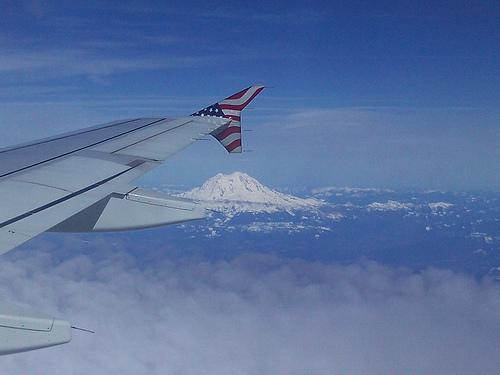Using as many details as possible, describe the view from the airplane. An airplane flying in a sunny clear blue sky, with a lot of white clouds below, snowy mountains in the distance, and the American flag printed on a wing. Count the number of mountains and describe their appearance in the image. There are two primary mountains, a large snow-covered mountain and a smaller mountain in the back, with a snowy landscape and rocks around them. Consider the elements in the image and summarize them while expressing a sense of admiration. An awe-inspiring view of an airplane with a patriotic wing soaring above mesmerizing clouds and majestic snow-capped mountains on a bright, sunny day. Can you provide a brief summary of the image's overall scenery? The image captures an airplane flying over snowy mountains and clouds, with a clear blue sky on a sunny day. What is the primary object and focus of this image? The primary object and focus is an airplane with a decorated wing, flying over clouds and mountains. Explain how the image might make someone feel who is looking at it. The image might evoke feelings of adventure, excitement, and freedom as the viewer observes the airplane flying above the clouds and snowy mountains on a sunny day. In the image, what type of natural formations are present, and how do they appear? There are large snow-covered mountains and smaller mountains in the background, with rocks out around the mountain, and fluffy white clouds below the plane. What is in the image regarding the weather? A clear blue sky with many fluffy white clouds in the sky, and it's a beautiful sunny day. What are some of the distinct features and details visible on the airplane's wing? An American flag design, a small wire sticking out of the wing, metal fuselage, flap on the wing, a wing fin on a jet plane, and white and red patterns. Identify and describe the flying object in the image. An airplane flying in a sunny day with an American flag wing tip, a small part of a wing, and flaps on the wing of a plane. 